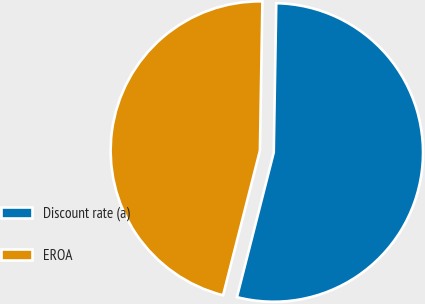Convert chart to OTSL. <chart><loc_0><loc_0><loc_500><loc_500><pie_chart><fcel>Discount rate (a)<fcel>EROA<nl><fcel>53.7%<fcel>46.3%<nl></chart> 